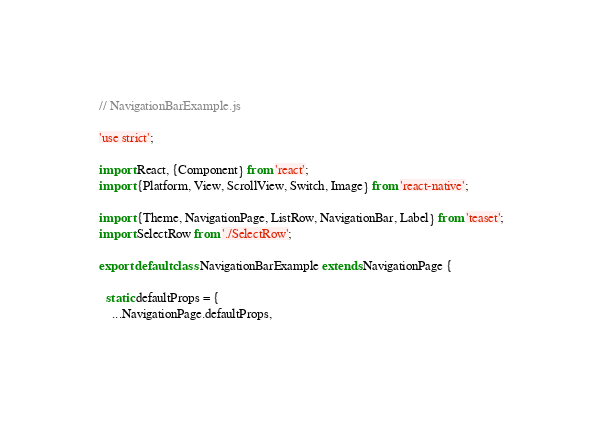<code> <loc_0><loc_0><loc_500><loc_500><_JavaScript_>// NavigationBarExample.js

'use strict';

import React, {Component} from 'react';
import {Platform, View, ScrollView, Switch, Image} from 'react-native';

import {Theme, NavigationPage, ListRow, NavigationBar, Label} from 'teaset';
import SelectRow from './SelectRow';

export default class NavigationBarExample extends NavigationPage {

  static defaultProps = {
    ...NavigationPage.defaultProps,</code> 